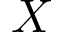Convert formula to latex. <formula><loc_0><loc_0><loc_500><loc_500>X</formula> 